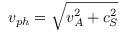Convert formula to latex. <formula><loc_0><loc_0><loc_500><loc_500>v _ { p h } = \sqrt { v _ { A } ^ { 2 } + c _ { S } ^ { 2 } }</formula> 